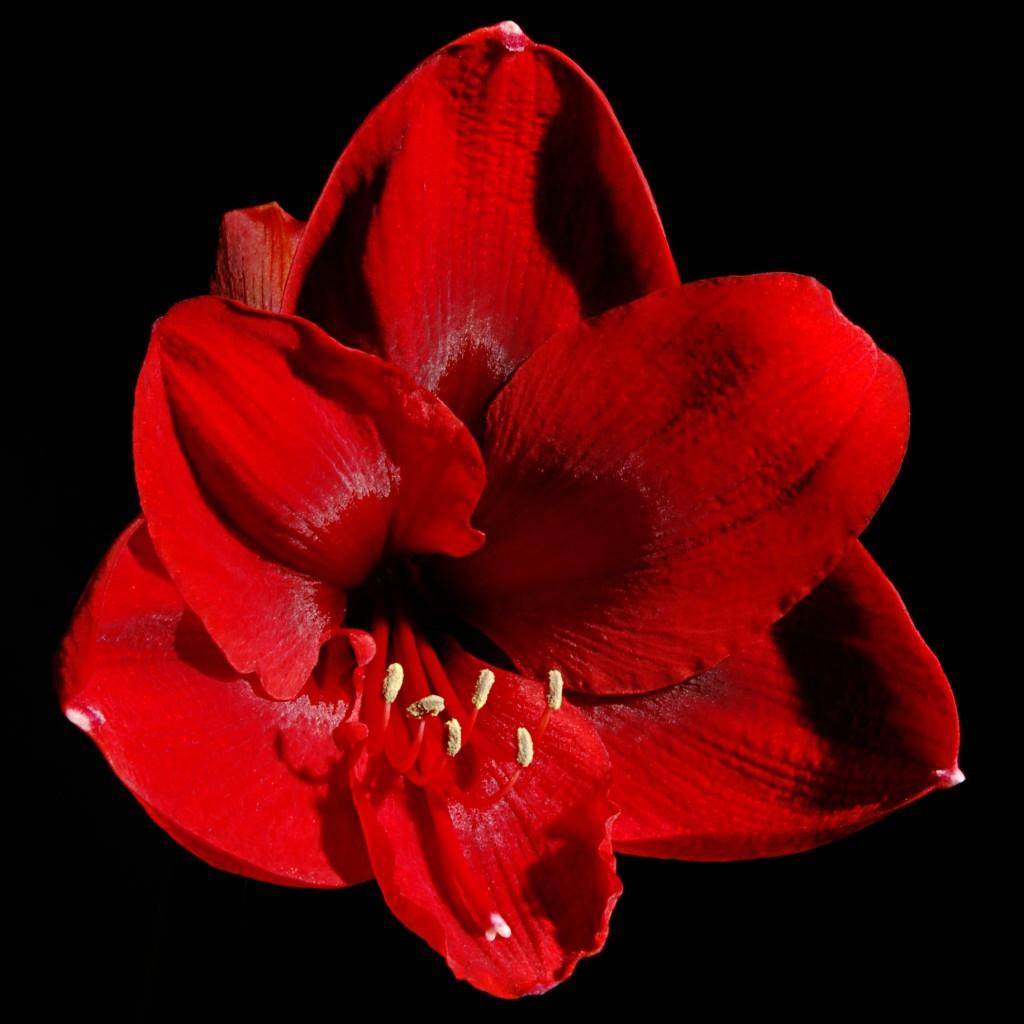What type of flower is in the image? There is a red flower in the image. What color is the background of the image? The background of the image is black. How many lizards are crawling on the red flower in the image? There are no lizards present in the image; it only features a red flower against a black background. What type of sail is visible in the image? There is no sail present in the image. 